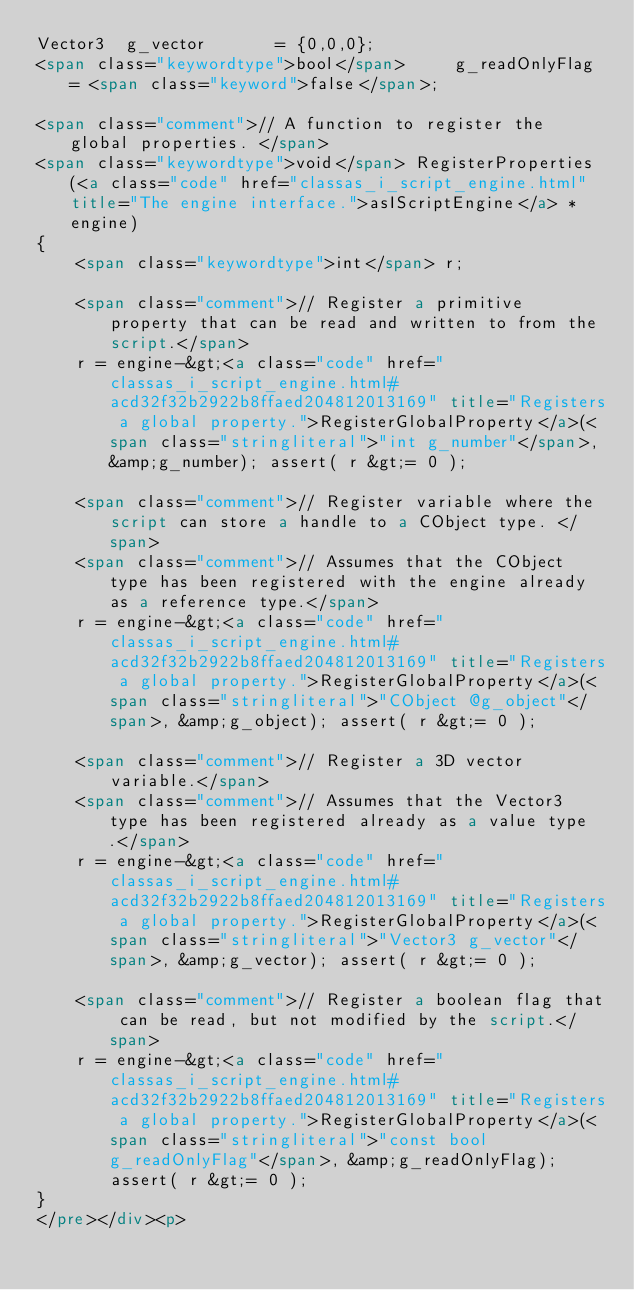<code> <loc_0><loc_0><loc_500><loc_500><_HTML_>Vector3  g_vector       = {0,0,0};
<span class="keywordtype">bool</span>     g_readOnlyFlag = <span class="keyword">false</span>;

<span class="comment">// A function to register the global properties. </span>
<span class="keywordtype">void</span> RegisterProperties(<a class="code" href="classas_i_script_engine.html" title="The engine interface.">asIScriptEngine</a> *engine)
{
    <span class="keywordtype">int</span> r;
    
    <span class="comment">// Register a primitive property that can be read and written to from the script.</span>
    r = engine-&gt;<a class="code" href="classas_i_script_engine.html#acd32f32b2922b8ffaed204812013169" title="Registers a global property.">RegisterGlobalProperty</a>(<span class="stringliteral">"int g_number"</span>, &amp;g_number); assert( r &gt;= 0 );
    
    <span class="comment">// Register variable where the script can store a handle to a CObject type. </span>
    <span class="comment">// Assumes that the CObject type has been registered with the engine already as a reference type.</span>
    r = engine-&gt;<a class="code" href="classas_i_script_engine.html#acd32f32b2922b8ffaed204812013169" title="Registers a global property.">RegisterGlobalProperty</a>(<span class="stringliteral">"CObject @g_object"</span>, &amp;g_object); assert( r &gt;= 0 );
    
    <span class="comment">// Register a 3D vector variable.</span>
    <span class="comment">// Assumes that the Vector3 type has been registered already as a value type.</span>
    r = engine-&gt;<a class="code" href="classas_i_script_engine.html#acd32f32b2922b8ffaed204812013169" title="Registers a global property.">RegisterGlobalProperty</a>(<span class="stringliteral">"Vector3 g_vector"</span>, &amp;g_vector); assert( r &gt;= 0 );
    
    <span class="comment">// Register a boolean flag that can be read, but not modified by the script.</span>
    r = engine-&gt;<a class="code" href="classas_i_script_engine.html#acd32f32b2922b8ffaed204812013169" title="Registers a global property.">RegisterGlobalProperty</a>(<span class="stringliteral">"const bool g_readOnlyFlag"</span>, &amp;g_readOnlyFlag); assert( r &gt;= 0 );
}
</pre></div><p></code> 